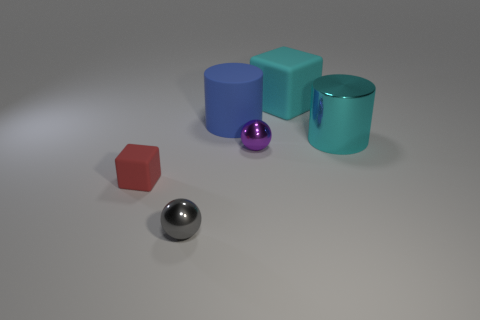What color is the matte cube in front of the block that is to the right of the block left of the big block?
Provide a succinct answer. Red. There is a rubber cube that is to the left of the small gray ball; is it the same color as the big matte block?
Offer a terse response. No. How many other objects are the same color as the big metal thing?
Provide a succinct answer. 1. What number of objects are purple spheres or tiny red rubber cubes?
Offer a terse response. 2. What number of things are either yellow matte balls or matte things left of the cyan rubber thing?
Offer a terse response. 2. Is the material of the gray sphere the same as the blue cylinder?
Your response must be concise. No. Is the number of small yellow cylinders greater than the number of big rubber objects?
Your response must be concise. No. There is a big matte object to the left of the small purple sphere; does it have the same shape as the tiny rubber thing?
Your answer should be compact. No. Is the number of rubber spheres less than the number of tiny gray balls?
Provide a short and direct response. Yes. What material is the other cylinder that is the same size as the blue cylinder?
Keep it short and to the point. Metal. 